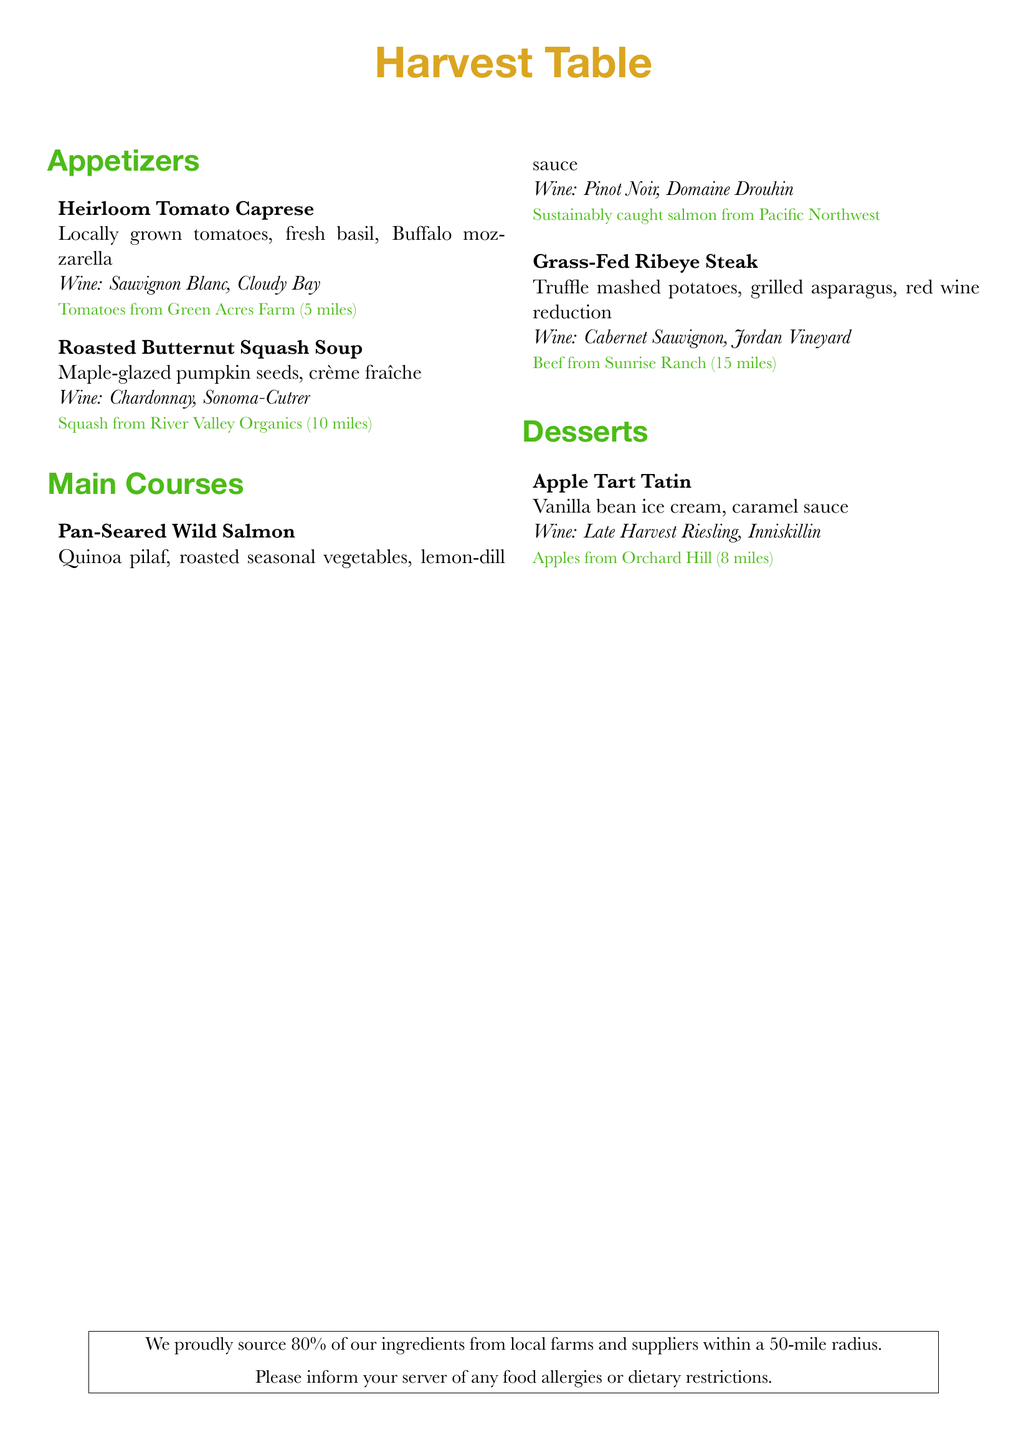what is the name of the restaurant? The restaurant's name is prominently displayed at the top of the menu document.
Answer: Harvest Table how many miles is Green Acres Farm from the restaurant? The distance of Green Acres Farm is noted in the appetizer section next to the heirloom tomatoes.
Answer: 5 miles what type of cheese is used in the Heirloom Tomato Caprese? The menu specifies the cheese used in this appetizer.
Answer: Buffalo mozzarella which wine is paired with the Grass-Fed Ribeye Steak? The wine pairing is mentioned alongside the corresponding main course.
Answer: Cabernet Sauvignon, Jordan Vineyard where does the squash for the Roasted Butternut Squash Soup come from? The source of the squash is indicated in the description of the dish.
Answer: River Valley Organics what percentage of ingredients is sourced from local farms? This information is provided at the bottom of the menu, summarizing the restaurant's sourcing practices.
Answer: 80% what type of dessert features apples from Orchard Hill? The dessert section specifies this dish as made with the locally sourced fruit.
Answer: Apple Tart Tatin how are the salmon sourced for the Pan-Seared Wild Salmon dish described? The description includes details on how the salmon is caught.
Answer: Sustainably caught 